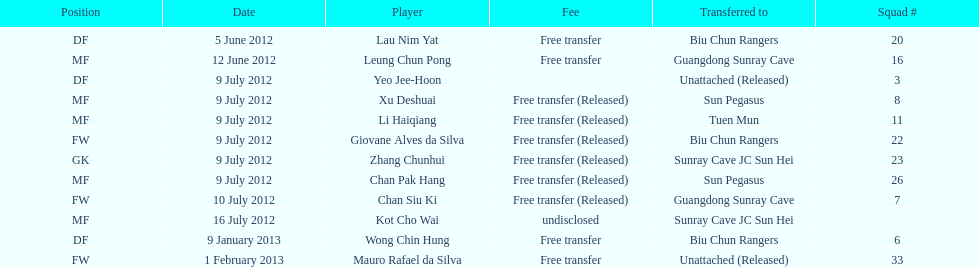Help me parse the entirety of this table. {'header': ['Position', 'Date', 'Player', 'Fee', 'Transferred to', 'Squad #'], 'rows': [['DF', '5 June 2012', 'Lau Nim Yat', 'Free transfer', 'Biu Chun Rangers', '20'], ['MF', '12 June 2012', 'Leung Chun Pong', 'Free transfer', 'Guangdong Sunray Cave', '16'], ['DF', '9 July 2012', 'Yeo Jee-Hoon', '', 'Unattached (Released)', '3'], ['MF', '9 July 2012', 'Xu Deshuai', 'Free transfer (Released)', 'Sun Pegasus', '8'], ['MF', '9 July 2012', 'Li Haiqiang', 'Free transfer (Released)', 'Tuen Mun', '11'], ['FW', '9 July 2012', 'Giovane Alves da Silva', 'Free transfer (Released)', 'Biu Chun Rangers', '22'], ['GK', '9 July 2012', 'Zhang Chunhui', 'Free transfer (Released)', 'Sunray Cave JC Sun Hei', '23'], ['MF', '9 July 2012', 'Chan Pak Hang', 'Free transfer (Released)', 'Sun Pegasus', '26'], ['FW', '10 July 2012', 'Chan Siu Ki', 'Free transfer (Released)', 'Guangdong Sunray Cave', '7'], ['MF', '16 July 2012', 'Kot Cho Wai', 'undisclosed', 'Sunray Cave JC Sun Hei', ''], ['DF', '9 January 2013', 'Wong Chin Hung', 'Free transfer', 'Biu Chun Rangers', '6'], ['FW', '1 February 2013', 'Mauro Rafael da Silva', 'Free transfer', 'Unattached (Released)', '33']]} For which position were li haiqiang and xu deshuai both known to play? MF. 